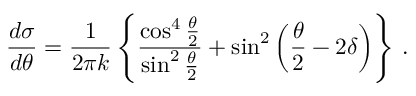<formula> <loc_0><loc_0><loc_500><loc_500>\frac { d \sigma } { d \theta } = \frac { 1 } { 2 \pi k } \left \{ \frac { \cos ^ { 4 } \frac { \theta } { 2 } } { \sin ^ { 2 } \frac { \theta } { 2 } } + \sin ^ { 2 } \left ( \frac { \theta } { 2 } - 2 \delta \right ) \right \} \, .</formula> 